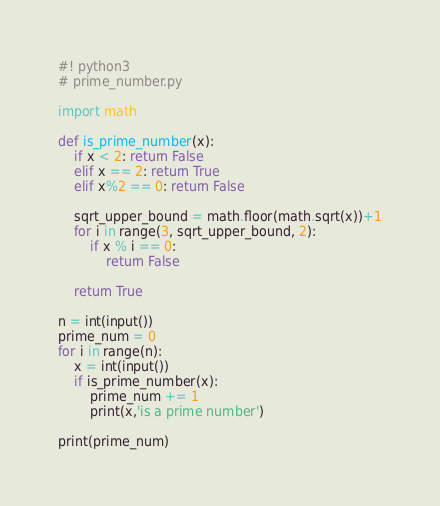Convert code to text. <code><loc_0><loc_0><loc_500><loc_500><_Python_>#! python3
# prime_number.py

import math

def is_prime_number(x):
    if x < 2: return False
    elif x == 2: return True
    elif x%2 == 0: return False

    sqrt_upper_bound = math.floor(math.sqrt(x))+1
    for i in range(3, sqrt_upper_bound, 2):
        if x % i == 0:
            return False

    return True

n = int(input())
prime_num = 0
for i in range(n):
    x = int(input())
    if is_prime_number(x):
        prime_num += 1
        print(x,'is a prime number')

print(prime_num)
</code> 